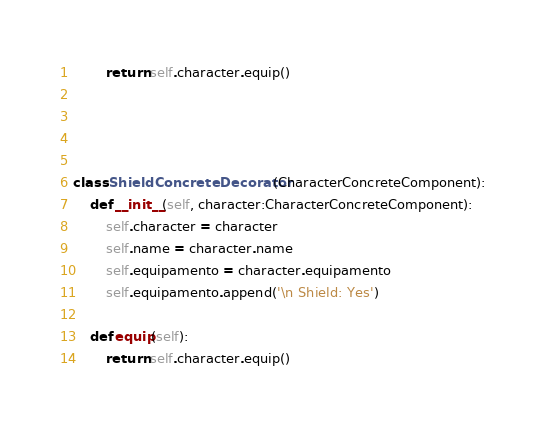<code> <loc_0><loc_0><loc_500><loc_500><_Python_>        return self.character.equip() 




class ShieldConcreteDecorator(CharacterConcreteComponent):
    def __init__(self, character:CharacterConcreteComponent):
        self.character = character
        self.name = character.name
        self.equipamento = character.equipamento
        self.equipamento.append('\n Shield: Yes')

    def equip(self):
        return self.character.equip()</code> 